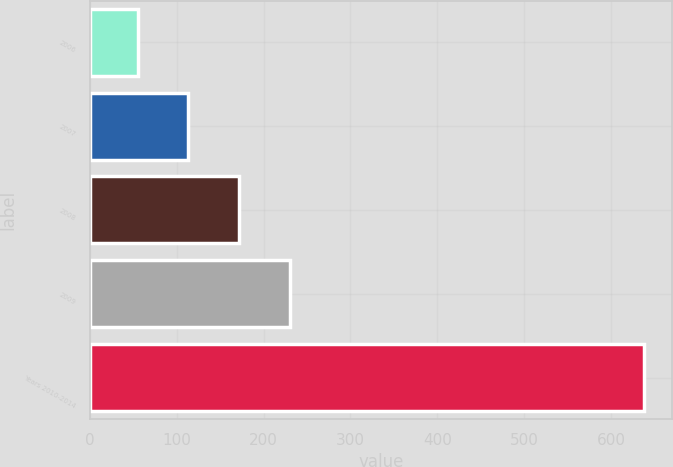<chart> <loc_0><loc_0><loc_500><loc_500><bar_chart><fcel>2006<fcel>2007<fcel>2008<fcel>2009<fcel>Years 2010-2014<nl><fcel>55<fcel>113.3<fcel>171.6<fcel>229.9<fcel>638<nl></chart> 